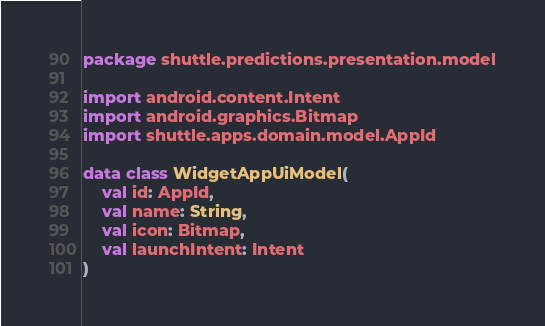Convert code to text. <code><loc_0><loc_0><loc_500><loc_500><_Kotlin_>package shuttle.predictions.presentation.model

import android.content.Intent
import android.graphics.Bitmap
import shuttle.apps.domain.model.AppId

data class WidgetAppUiModel(
    val id: AppId,
    val name: String,
    val icon: Bitmap,
    val launchIntent: Intent
)
</code> 